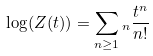<formula> <loc_0><loc_0><loc_500><loc_500>\log ( Z ( t ) ) = \sum _ { n \geq 1 } \L _ { n } \frac { t ^ { n } } { n ! }</formula> 